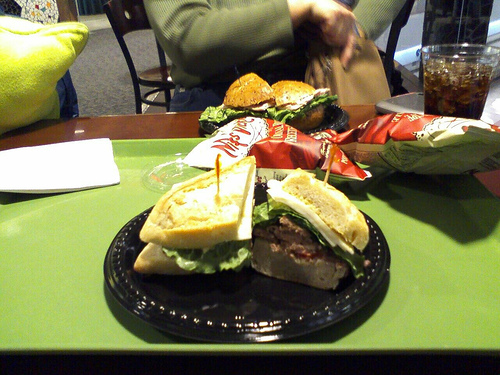Identify and read out the text in this image. Niss 